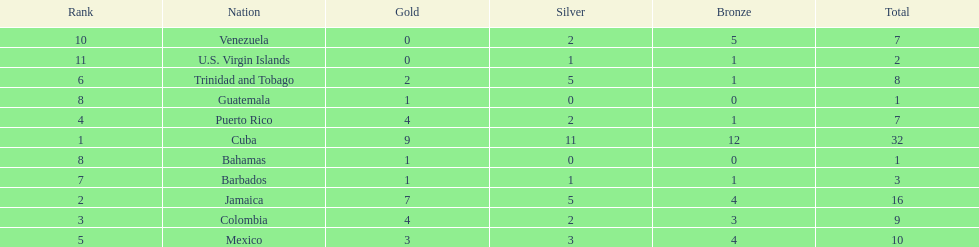Could you parse the entire table? {'header': ['Rank', 'Nation', 'Gold', 'Silver', 'Bronze', 'Total'], 'rows': [['10', 'Venezuela', '0', '2', '5', '7'], ['11', 'U.S. Virgin Islands', '0', '1', '1', '2'], ['6', 'Trinidad and Tobago', '2', '5', '1', '8'], ['8', 'Guatemala', '1', '0', '0', '1'], ['4', 'Puerto Rico', '4', '2', '1', '7'], ['1', 'Cuba', '9', '11', '12', '32'], ['8', 'Bahamas', '1', '0', '0', '1'], ['7', 'Barbados', '1', '1', '1', '3'], ['2', 'Jamaica', '7', '5', '4', '16'], ['3', 'Colombia', '4', '2', '3', '9'], ['5', 'Mexico', '3', '3', '4', '10']]} The nation before mexico in the table Puerto Rico. 